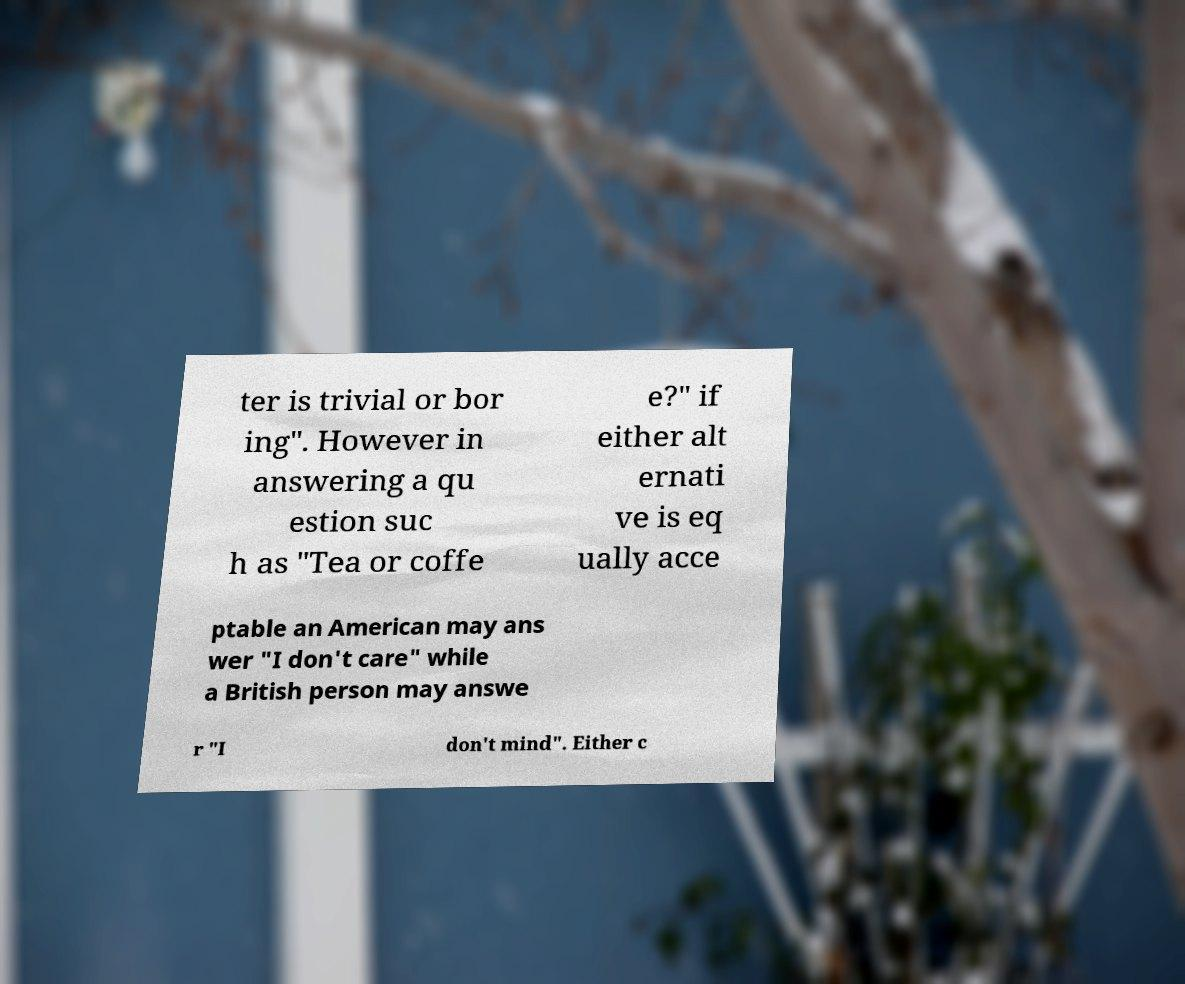Please read and relay the text visible in this image. What does it say? ter is trivial or bor ing". However in answering a qu estion suc h as "Tea or coffe e?" if either alt ernati ve is eq ually acce ptable an American may ans wer "I don't care" while a British person may answe r "I don't mind". Either c 